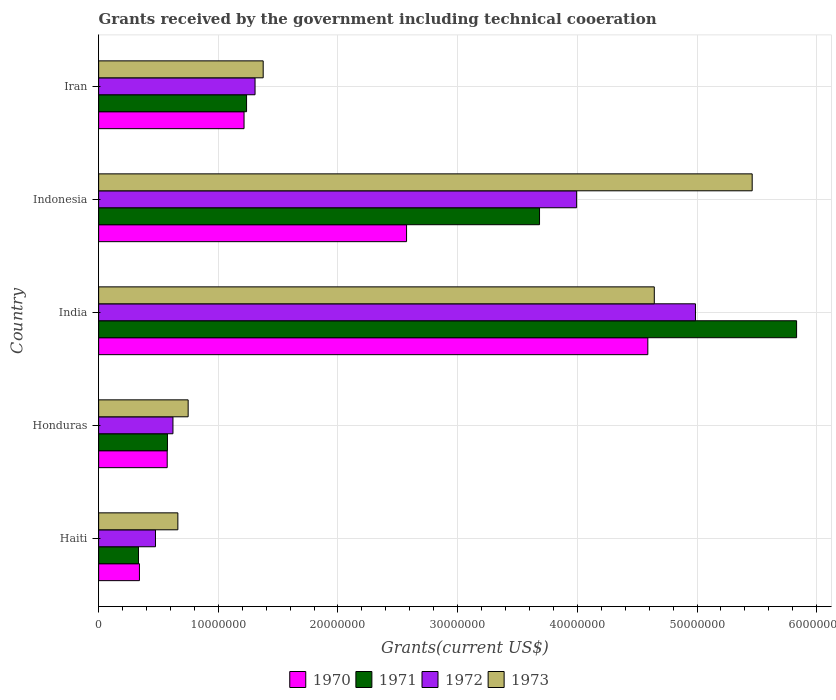How many groups of bars are there?
Your response must be concise. 5. Are the number of bars per tick equal to the number of legend labels?
Make the answer very short. Yes. Are the number of bars on each tick of the Y-axis equal?
Give a very brief answer. Yes. How many bars are there on the 1st tick from the top?
Your answer should be very brief. 4. What is the label of the 5th group of bars from the top?
Your answer should be very brief. Haiti. What is the total grants received by the government in 1973 in Indonesia?
Provide a short and direct response. 5.46e+07. Across all countries, what is the maximum total grants received by the government in 1973?
Your answer should be compact. 5.46e+07. Across all countries, what is the minimum total grants received by the government in 1970?
Make the answer very short. 3.41e+06. In which country was the total grants received by the government in 1972 minimum?
Your response must be concise. Haiti. What is the total total grants received by the government in 1970 in the graph?
Keep it short and to the point. 9.29e+07. What is the difference between the total grants received by the government in 1973 in India and that in Indonesia?
Provide a succinct answer. -8.18e+06. What is the difference between the total grants received by the government in 1971 in India and the total grants received by the government in 1972 in Honduras?
Offer a very short reply. 5.21e+07. What is the average total grants received by the government in 1972 per country?
Offer a terse response. 2.28e+07. What is the ratio of the total grants received by the government in 1971 in Honduras to that in India?
Your answer should be compact. 0.1. Is the total grants received by the government in 1970 in Honduras less than that in Indonesia?
Make the answer very short. Yes. What is the difference between the highest and the second highest total grants received by the government in 1970?
Ensure brevity in your answer.  2.02e+07. What is the difference between the highest and the lowest total grants received by the government in 1971?
Give a very brief answer. 5.50e+07. In how many countries, is the total grants received by the government in 1973 greater than the average total grants received by the government in 1973 taken over all countries?
Provide a short and direct response. 2. Is the sum of the total grants received by the government in 1973 in Honduras and Indonesia greater than the maximum total grants received by the government in 1970 across all countries?
Ensure brevity in your answer.  Yes. Is it the case that in every country, the sum of the total grants received by the government in 1973 and total grants received by the government in 1970 is greater than the sum of total grants received by the government in 1972 and total grants received by the government in 1971?
Your answer should be very brief. Yes. What does the 1st bar from the top in Iran represents?
Offer a very short reply. 1973. How many bars are there?
Keep it short and to the point. 20. Are all the bars in the graph horizontal?
Ensure brevity in your answer.  Yes. Does the graph contain any zero values?
Make the answer very short. No. Does the graph contain grids?
Make the answer very short. Yes. Where does the legend appear in the graph?
Your answer should be compact. Bottom center. How are the legend labels stacked?
Your response must be concise. Horizontal. What is the title of the graph?
Offer a terse response. Grants received by the government including technical cooeration. What is the label or title of the X-axis?
Offer a terse response. Grants(current US$). What is the Grants(current US$) in 1970 in Haiti?
Provide a short and direct response. 3.41e+06. What is the Grants(current US$) of 1971 in Haiti?
Provide a succinct answer. 3.33e+06. What is the Grants(current US$) in 1972 in Haiti?
Your answer should be very brief. 4.75e+06. What is the Grants(current US$) of 1973 in Haiti?
Offer a terse response. 6.62e+06. What is the Grants(current US$) in 1970 in Honduras?
Your answer should be compact. 5.73e+06. What is the Grants(current US$) of 1971 in Honduras?
Make the answer very short. 5.75e+06. What is the Grants(current US$) in 1972 in Honduras?
Give a very brief answer. 6.21e+06. What is the Grants(current US$) of 1973 in Honduras?
Make the answer very short. 7.48e+06. What is the Grants(current US$) in 1970 in India?
Your answer should be very brief. 4.59e+07. What is the Grants(current US$) of 1971 in India?
Make the answer very short. 5.83e+07. What is the Grants(current US$) in 1972 in India?
Provide a short and direct response. 4.99e+07. What is the Grants(current US$) of 1973 in India?
Provide a short and direct response. 4.64e+07. What is the Grants(current US$) in 1970 in Indonesia?
Provide a short and direct response. 2.57e+07. What is the Grants(current US$) in 1971 in Indonesia?
Your answer should be very brief. 3.68e+07. What is the Grants(current US$) of 1972 in Indonesia?
Your answer should be very brief. 3.99e+07. What is the Grants(current US$) of 1973 in Indonesia?
Offer a very short reply. 5.46e+07. What is the Grants(current US$) in 1970 in Iran?
Offer a terse response. 1.22e+07. What is the Grants(current US$) of 1971 in Iran?
Provide a succinct answer. 1.24e+07. What is the Grants(current US$) of 1972 in Iran?
Ensure brevity in your answer.  1.31e+07. What is the Grants(current US$) of 1973 in Iran?
Provide a short and direct response. 1.38e+07. Across all countries, what is the maximum Grants(current US$) in 1970?
Ensure brevity in your answer.  4.59e+07. Across all countries, what is the maximum Grants(current US$) of 1971?
Offer a very short reply. 5.83e+07. Across all countries, what is the maximum Grants(current US$) in 1972?
Offer a very short reply. 4.99e+07. Across all countries, what is the maximum Grants(current US$) in 1973?
Provide a short and direct response. 5.46e+07. Across all countries, what is the minimum Grants(current US$) of 1970?
Give a very brief answer. 3.41e+06. Across all countries, what is the minimum Grants(current US$) in 1971?
Offer a terse response. 3.33e+06. Across all countries, what is the minimum Grants(current US$) in 1972?
Offer a very short reply. 4.75e+06. Across all countries, what is the minimum Grants(current US$) in 1973?
Provide a succinct answer. 6.62e+06. What is the total Grants(current US$) of 1970 in the graph?
Keep it short and to the point. 9.29e+07. What is the total Grants(current US$) of 1971 in the graph?
Your response must be concise. 1.17e+08. What is the total Grants(current US$) of 1972 in the graph?
Provide a short and direct response. 1.14e+08. What is the total Grants(current US$) of 1973 in the graph?
Your response must be concise. 1.29e+08. What is the difference between the Grants(current US$) of 1970 in Haiti and that in Honduras?
Provide a succinct answer. -2.32e+06. What is the difference between the Grants(current US$) of 1971 in Haiti and that in Honduras?
Offer a very short reply. -2.42e+06. What is the difference between the Grants(current US$) in 1972 in Haiti and that in Honduras?
Provide a short and direct response. -1.46e+06. What is the difference between the Grants(current US$) of 1973 in Haiti and that in Honduras?
Ensure brevity in your answer.  -8.60e+05. What is the difference between the Grants(current US$) of 1970 in Haiti and that in India?
Offer a very short reply. -4.25e+07. What is the difference between the Grants(current US$) of 1971 in Haiti and that in India?
Your answer should be compact. -5.50e+07. What is the difference between the Grants(current US$) in 1972 in Haiti and that in India?
Your answer should be compact. -4.51e+07. What is the difference between the Grants(current US$) of 1973 in Haiti and that in India?
Offer a very short reply. -3.98e+07. What is the difference between the Grants(current US$) of 1970 in Haiti and that in Indonesia?
Keep it short and to the point. -2.23e+07. What is the difference between the Grants(current US$) in 1971 in Haiti and that in Indonesia?
Ensure brevity in your answer.  -3.35e+07. What is the difference between the Grants(current US$) of 1972 in Haiti and that in Indonesia?
Offer a terse response. -3.52e+07. What is the difference between the Grants(current US$) of 1973 in Haiti and that in Indonesia?
Offer a very short reply. -4.80e+07. What is the difference between the Grants(current US$) of 1970 in Haiti and that in Iran?
Provide a succinct answer. -8.74e+06. What is the difference between the Grants(current US$) in 1971 in Haiti and that in Iran?
Keep it short and to the point. -9.03e+06. What is the difference between the Grants(current US$) in 1972 in Haiti and that in Iran?
Keep it short and to the point. -8.32e+06. What is the difference between the Grants(current US$) of 1973 in Haiti and that in Iran?
Offer a very short reply. -7.13e+06. What is the difference between the Grants(current US$) in 1970 in Honduras and that in India?
Give a very brief answer. -4.02e+07. What is the difference between the Grants(current US$) of 1971 in Honduras and that in India?
Provide a succinct answer. -5.26e+07. What is the difference between the Grants(current US$) in 1972 in Honduras and that in India?
Ensure brevity in your answer.  -4.37e+07. What is the difference between the Grants(current US$) of 1973 in Honduras and that in India?
Make the answer very short. -3.90e+07. What is the difference between the Grants(current US$) of 1970 in Honduras and that in Indonesia?
Offer a terse response. -2.00e+07. What is the difference between the Grants(current US$) of 1971 in Honduras and that in Indonesia?
Offer a very short reply. -3.11e+07. What is the difference between the Grants(current US$) in 1972 in Honduras and that in Indonesia?
Provide a succinct answer. -3.37e+07. What is the difference between the Grants(current US$) of 1973 in Honduras and that in Indonesia?
Offer a terse response. -4.71e+07. What is the difference between the Grants(current US$) in 1970 in Honduras and that in Iran?
Keep it short and to the point. -6.42e+06. What is the difference between the Grants(current US$) in 1971 in Honduras and that in Iran?
Make the answer very short. -6.61e+06. What is the difference between the Grants(current US$) in 1972 in Honduras and that in Iran?
Ensure brevity in your answer.  -6.86e+06. What is the difference between the Grants(current US$) in 1973 in Honduras and that in Iran?
Your response must be concise. -6.27e+06. What is the difference between the Grants(current US$) in 1970 in India and that in Indonesia?
Offer a terse response. 2.02e+07. What is the difference between the Grants(current US$) in 1971 in India and that in Indonesia?
Your answer should be very brief. 2.15e+07. What is the difference between the Grants(current US$) of 1972 in India and that in Indonesia?
Make the answer very short. 9.93e+06. What is the difference between the Grants(current US$) in 1973 in India and that in Indonesia?
Ensure brevity in your answer.  -8.18e+06. What is the difference between the Grants(current US$) in 1970 in India and that in Iran?
Keep it short and to the point. 3.37e+07. What is the difference between the Grants(current US$) in 1971 in India and that in Iran?
Your response must be concise. 4.60e+07. What is the difference between the Grants(current US$) in 1972 in India and that in Iran?
Provide a short and direct response. 3.68e+07. What is the difference between the Grants(current US$) of 1973 in India and that in Iran?
Ensure brevity in your answer.  3.27e+07. What is the difference between the Grants(current US$) of 1970 in Indonesia and that in Iran?
Your response must be concise. 1.36e+07. What is the difference between the Grants(current US$) of 1971 in Indonesia and that in Iran?
Ensure brevity in your answer.  2.45e+07. What is the difference between the Grants(current US$) in 1972 in Indonesia and that in Iran?
Give a very brief answer. 2.69e+07. What is the difference between the Grants(current US$) of 1973 in Indonesia and that in Iran?
Ensure brevity in your answer.  4.09e+07. What is the difference between the Grants(current US$) in 1970 in Haiti and the Grants(current US$) in 1971 in Honduras?
Provide a short and direct response. -2.34e+06. What is the difference between the Grants(current US$) in 1970 in Haiti and the Grants(current US$) in 1972 in Honduras?
Keep it short and to the point. -2.80e+06. What is the difference between the Grants(current US$) of 1970 in Haiti and the Grants(current US$) of 1973 in Honduras?
Your answer should be very brief. -4.07e+06. What is the difference between the Grants(current US$) of 1971 in Haiti and the Grants(current US$) of 1972 in Honduras?
Offer a very short reply. -2.88e+06. What is the difference between the Grants(current US$) in 1971 in Haiti and the Grants(current US$) in 1973 in Honduras?
Make the answer very short. -4.15e+06. What is the difference between the Grants(current US$) of 1972 in Haiti and the Grants(current US$) of 1973 in Honduras?
Offer a very short reply. -2.73e+06. What is the difference between the Grants(current US$) of 1970 in Haiti and the Grants(current US$) of 1971 in India?
Offer a very short reply. -5.49e+07. What is the difference between the Grants(current US$) in 1970 in Haiti and the Grants(current US$) in 1972 in India?
Your answer should be compact. -4.65e+07. What is the difference between the Grants(current US$) of 1970 in Haiti and the Grants(current US$) of 1973 in India?
Keep it short and to the point. -4.30e+07. What is the difference between the Grants(current US$) in 1971 in Haiti and the Grants(current US$) in 1972 in India?
Offer a terse response. -4.65e+07. What is the difference between the Grants(current US$) of 1971 in Haiti and the Grants(current US$) of 1973 in India?
Provide a succinct answer. -4.31e+07. What is the difference between the Grants(current US$) of 1972 in Haiti and the Grants(current US$) of 1973 in India?
Your answer should be very brief. -4.17e+07. What is the difference between the Grants(current US$) in 1970 in Haiti and the Grants(current US$) in 1971 in Indonesia?
Make the answer very short. -3.34e+07. What is the difference between the Grants(current US$) in 1970 in Haiti and the Grants(current US$) in 1972 in Indonesia?
Provide a succinct answer. -3.65e+07. What is the difference between the Grants(current US$) of 1970 in Haiti and the Grants(current US$) of 1973 in Indonesia?
Ensure brevity in your answer.  -5.12e+07. What is the difference between the Grants(current US$) of 1971 in Haiti and the Grants(current US$) of 1972 in Indonesia?
Provide a succinct answer. -3.66e+07. What is the difference between the Grants(current US$) of 1971 in Haiti and the Grants(current US$) of 1973 in Indonesia?
Make the answer very short. -5.13e+07. What is the difference between the Grants(current US$) in 1972 in Haiti and the Grants(current US$) in 1973 in Indonesia?
Ensure brevity in your answer.  -4.99e+07. What is the difference between the Grants(current US$) of 1970 in Haiti and the Grants(current US$) of 1971 in Iran?
Ensure brevity in your answer.  -8.95e+06. What is the difference between the Grants(current US$) in 1970 in Haiti and the Grants(current US$) in 1972 in Iran?
Your response must be concise. -9.66e+06. What is the difference between the Grants(current US$) in 1970 in Haiti and the Grants(current US$) in 1973 in Iran?
Provide a short and direct response. -1.03e+07. What is the difference between the Grants(current US$) of 1971 in Haiti and the Grants(current US$) of 1972 in Iran?
Provide a short and direct response. -9.74e+06. What is the difference between the Grants(current US$) of 1971 in Haiti and the Grants(current US$) of 1973 in Iran?
Give a very brief answer. -1.04e+07. What is the difference between the Grants(current US$) in 1972 in Haiti and the Grants(current US$) in 1973 in Iran?
Provide a succinct answer. -9.00e+06. What is the difference between the Grants(current US$) of 1970 in Honduras and the Grants(current US$) of 1971 in India?
Provide a short and direct response. -5.26e+07. What is the difference between the Grants(current US$) of 1970 in Honduras and the Grants(current US$) of 1972 in India?
Your answer should be very brief. -4.41e+07. What is the difference between the Grants(current US$) in 1970 in Honduras and the Grants(current US$) in 1973 in India?
Offer a very short reply. -4.07e+07. What is the difference between the Grants(current US$) of 1971 in Honduras and the Grants(current US$) of 1972 in India?
Offer a terse response. -4.41e+07. What is the difference between the Grants(current US$) in 1971 in Honduras and the Grants(current US$) in 1973 in India?
Your answer should be very brief. -4.07e+07. What is the difference between the Grants(current US$) of 1972 in Honduras and the Grants(current US$) of 1973 in India?
Give a very brief answer. -4.02e+07. What is the difference between the Grants(current US$) in 1970 in Honduras and the Grants(current US$) in 1971 in Indonesia?
Give a very brief answer. -3.11e+07. What is the difference between the Grants(current US$) in 1970 in Honduras and the Grants(current US$) in 1972 in Indonesia?
Your answer should be very brief. -3.42e+07. What is the difference between the Grants(current US$) in 1970 in Honduras and the Grants(current US$) in 1973 in Indonesia?
Give a very brief answer. -4.89e+07. What is the difference between the Grants(current US$) in 1971 in Honduras and the Grants(current US$) in 1972 in Indonesia?
Make the answer very short. -3.42e+07. What is the difference between the Grants(current US$) in 1971 in Honduras and the Grants(current US$) in 1973 in Indonesia?
Provide a succinct answer. -4.89e+07. What is the difference between the Grants(current US$) of 1972 in Honduras and the Grants(current US$) of 1973 in Indonesia?
Provide a short and direct response. -4.84e+07. What is the difference between the Grants(current US$) in 1970 in Honduras and the Grants(current US$) in 1971 in Iran?
Offer a terse response. -6.63e+06. What is the difference between the Grants(current US$) in 1970 in Honduras and the Grants(current US$) in 1972 in Iran?
Your answer should be compact. -7.34e+06. What is the difference between the Grants(current US$) of 1970 in Honduras and the Grants(current US$) of 1973 in Iran?
Your answer should be compact. -8.02e+06. What is the difference between the Grants(current US$) in 1971 in Honduras and the Grants(current US$) in 1972 in Iran?
Provide a short and direct response. -7.32e+06. What is the difference between the Grants(current US$) in 1971 in Honduras and the Grants(current US$) in 1973 in Iran?
Provide a succinct answer. -8.00e+06. What is the difference between the Grants(current US$) in 1972 in Honduras and the Grants(current US$) in 1973 in Iran?
Your response must be concise. -7.54e+06. What is the difference between the Grants(current US$) of 1970 in India and the Grants(current US$) of 1971 in Indonesia?
Ensure brevity in your answer.  9.05e+06. What is the difference between the Grants(current US$) in 1970 in India and the Grants(current US$) in 1972 in Indonesia?
Offer a terse response. 5.95e+06. What is the difference between the Grants(current US$) in 1970 in India and the Grants(current US$) in 1973 in Indonesia?
Your response must be concise. -8.72e+06. What is the difference between the Grants(current US$) in 1971 in India and the Grants(current US$) in 1972 in Indonesia?
Your answer should be very brief. 1.84e+07. What is the difference between the Grants(current US$) in 1971 in India and the Grants(current US$) in 1973 in Indonesia?
Offer a very short reply. 3.71e+06. What is the difference between the Grants(current US$) in 1972 in India and the Grants(current US$) in 1973 in Indonesia?
Offer a very short reply. -4.74e+06. What is the difference between the Grants(current US$) in 1970 in India and the Grants(current US$) in 1971 in Iran?
Offer a terse response. 3.35e+07. What is the difference between the Grants(current US$) in 1970 in India and the Grants(current US$) in 1972 in Iran?
Offer a terse response. 3.28e+07. What is the difference between the Grants(current US$) of 1970 in India and the Grants(current US$) of 1973 in Iran?
Keep it short and to the point. 3.21e+07. What is the difference between the Grants(current US$) of 1971 in India and the Grants(current US$) of 1972 in Iran?
Provide a short and direct response. 4.52e+07. What is the difference between the Grants(current US$) of 1971 in India and the Grants(current US$) of 1973 in Iran?
Offer a terse response. 4.46e+07. What is the difference between the Grants(current US$) in 1972 in India and the Grants(current US$) in 1973 in Iran?
Give a very brief answer. 3.61e+07. What is the difference between the Grants(current US$) in 1970 in Indonesia and the Grants(current US$) in 1971 in Iran?
Your answer should be compact. 1.34e+07. What is the difference between the Grants(current US$) in 1970 in Indonesia and the Grants(current US$) in 1972 in Iran?
Offer a terse response. 1.27e+07. What is the difference between the Grants(current US$) of 1970 in Indonesia and the Grants(current US$) of 1973 in Iran?
Offer a terse response. 1.20e+07. What is the difference between the Grants(current US$) in 1971 in Indonesia and the Grants(current US$) in 1972 in Iran?
Make the answer very short. 2.38e+07. What is the difference between the Grants(current US$) in 1971 in Indonesia and the Grants(current US$) in 1973 in Iran?
Your response must be concise. 2.31e+07. What is the difference between the Grants(current US$) of 1972 in Indonesia and the Grants(current US$) of 1973 in Iran?
Provide a short and direct response. 2.62e+07. What is the average Grants(current US$) in 1970 per country?
Provide a succinct answer. 1.86e+07. What is the average Grants(current US$) in 1971 per country?
Ensure brevity in your answer.  2.33e+07. What is the average Grants(current US$) in 1972 per country?
Offer a terse response. 2.28e+07. What is the average Grants(current US$) in 1973 per country?
Provide a succinct answer. 2.58e+07. What is the difference between the Grants(current US$) of 1970 and Grants(current US$) of 1972 in Haiti?
Make the answer very short. -1.34e+06. What is the difference between the Grants(current US$) in 1970 and Grants(current US$) in 1973 in Haiti?
Provide a succinct answer. -3.21e+06. What is the difference between the Grants(current US$) of 1971 and Grants(current US$) of 1972 in Haiti?
Your response must be concise. -1.42e+06. What is the difference between the Grants(current US$) in 1971 and Grants(current US$) in 1973 in Haiti?
Give a very brief answer. -3.29e+06. What is the difference between the Grants(current US$) in 1972 and Grants(current US$) in 1973 in Haiti?
Your answer should be compact. -1.87e+06. What is the difference between the Grants(current US$) of 1970 and Grants(current US$) of 1971 in Honduras?
Provide a succinct answer. -2.00e+04. What is the difference between the Grants(current US$) of 1970 and Grants(current US$) of 1972 in Honduras?
Your answer should be compact. -4.80e+05. What is the difference between the Grants(current US$) in 1970 and Grants(current US$) in 1973 in Honduras?
Offer a very short reply. -1.75e+06. What is the difference between the Grants(current US$) in 1971 and Grants(current US$) in 1972 in Honduras?
Offer a terse response. -4.60e+05. What is the difference between the Grants(current US$) of 1971 and Grants(current US$) of 1973 in Honduras?
Keep it short and to the point. -1.73e+06. What is the difference between the Grants(current US$) in 1972 and Grants(current US$) in 1973 in Honduras?
Offer a terse response. -1.27e+06. What is the difference between the Grants(current US$) in 1970 and Grants(current US$) in 1971 in India?
Your answer should be very brief. -1.24e+07. What is the difference between the Grants(current US$) in 1970 and Grants(current US$) in 1972 in India?
Make the answer very short. -3.98e+06. What is the difference between the Grants(current US$) of 1970 and Grants(current US$) of 1973 in India?
Provide a succinct answer. -5.40e+05. What is the difference between the Grants(current US$) of 1971 and Grants(current US$) of 1972 in India?
Offer a terse response. 8.45e+06. What is the difference between the Grants(current US$) in 1971 and Grants(current US$) in 1973 in India?
Offer a very short reply. 1.19e+07. What is the difference between the Grants(current US$) of 1972 and Grants(current US$) of 1973 in India?
Keep it short and to the point. 3.44e+06. What is the difference between the Grants(current US$) of 1970 and Grants(current US$) of 1971 in Indonesia?
Offer a very short reply. -1.11e+07. What is the difference between the Grants(current US$) in 1970 and Grants(current US$) in 1972 in Indonesia?
Keep it short and to the point. -1.42e+07. What is the difference between the Grants(current US$) in 1970 and Grants(current US$) in 1973 in Indonesia?
Offer a very short reply. -2.89e+07. What is the difference between the Grants(current US$) of 1971 and Grants(current US$) of 1972 in Indonesia?
Offer a very short reply. -3.10e+06. What is the difference between the Grants(current US$) of 1971 and Grants(current US$) of 1973 in Indonesia?
Your response must be concise. -1.78e+07. What is the difference between the Grants(current US$) of 1972 and Grants(current US$) of 1973 in Indonesia?
Make the answer very short. -1.47e+07. What is the difference between the Grants(current US$) of 1970 and Grants(current US$) of 1972 in Iran?
Ensure brevity in your answer.  -9.20e+05. What is the difference between the Grants(current US$) of 1970 and Grants(current US$) of 1973 in Iran?
Ensure brevity in your answer.  -1.60e+06. What is the difference between the Grants(current US$) in 1971 and Grants(current US$) in 1972 in Iran?
Keep it short and to the point. -7.10e+05. What is the difference between the Grants(current US$) of 1971 and Grants(current US$) of 1973 in Iran?
Provide a short and direct response. -1.39e+06. What is the difference between the Grants(current US$) in 1972 and Grants(current US$) in 1973 in Iran?
Provide a short and direct response. -6.80e+05. What is the ratio of the Grants(current US$) of 1970 in Haiti to that in Honduras?
Your response must be concise. 0.6. What is the ratio of the Grants(current US$) in 1971 in Haiti to that in Honduras?
Your answer should be compact. 0.58. What is the ratio of the Grants(current US$) in 1972 in Haiti to that in Honduras?
Make the answer very short. 0.76. What is the ratio of the Grants(current US$) of 1973 in Haiti to that in Honduras?
Give a very brief answer. 0.89. What is the ratio of the Grants(current US$) in 1970 in Haiti to that in India?
Provide a succinct answer. 0.07. What is the ratio of the Grants(current US$) of 1971 in Haiti to that in India?
Offer a terse response. 0.06. What is the ratio of the Grants(current US$) in 1972 in Haiti to that in India?
Your response must be concise. 0.1. What is the ratio of the Grants(current US$) in 1973 in Haiti to that in India?
Your answer should be compact. 0.14. What is the ratio of the Grants(current US$) of 1970 in Haiti to that in Indonesia?
Offer a very short reply. 0.13. What is the ratio of the Grants(current US$) in 1971 in Haiti to that in Indonesia?
Offer a very short reply. 0.09. What is the ratio of the Grants(current US$) in 1972 in Haiti to that in Indonesia?
Provide a short and direct response. 0.12. What is the ratio of the Grants(current US$) in 1973 in Haiti to that in Indonesia?
Offer a very short reply. 0.12. What is the ratio of the Grants(current US$) in 1970 in Haiti to that in Iran?
Your response must be concise. 0.28. What is the ratio of the Grants(current US$) of 1971 in Haiti to that in Iran?
Your answer should be very brief. 0.27. What is the ratio of the Grants(current US$) of 1972 in Haiti to that in Iran?
Ensure brevity in your answer.  0.36. What is the ratio of the Grants(current US$) of 1973 in Haiti to that in Iran?
Your answer should be compact. 0.48. What is the ratio of the Grants(current US$) of 1970 in Honduras to that in India?
Provide a short and direct response. 0.12. What is the ratio of the Grants(current US$) in 1971 in Honduras to that in India?
Your response must be concise. 0.1. What is the ratio of the Grants(current US$) of 1972 in Honduras to that in India?
Your answer should be very brief. 0.12. What is the ratio of the Grants(current US$) of 1973 in Honduras to that in India?
Your response must be concise. 0.16. What is the ratio of the Grants(current US$) of 1970 in Honduras to that in Indonesia?
Offer a very short reply. 0.22. What is the ratio of the Grants(current US$) of 1971 in Honduras to that in Indonesia?
Give a very brief answer. 0.16. What is the ratio of the Grants(current US$) in 1972 in Honduras to that in Indonesia?
Provide a succinct answer. 0.16. What is the ratio of the Grants(current US$) in 1973 in Honduras to that in Indonesia?
Your answer should be very brief. 0.14. What is the ratio of the Grants(current US$) in 1970 in Honduras to that in Iran?
Provide a succinct answer. 0.47. What is the ratio of the Grants(current US$) in 1971 in Honduras to that in Iran?
Offer a terse response. 0.47. What is the ratio of the Grants(current US$) of 1972 in Honduras to that in Iran?
Your answer should be very brief. 0.48. What is the ratio of the Grants(current US$) of 1973 in Honduras to that in Iran?
Your answer should be very brief. 0.54. What is the ratio of the Grants(current US$) in 1970 in India to that in Indonesia?
Your answer should be very brief. 1.78. What is the ratio of the Grants(current US$) in 1971 in India to that in Indonesia?
Keep it short and to the point. 1.58. What is the ratio of the Grants(current US$) of 1972 in India to that in Indonesia?
Keep it short and to the point. 1.25. What is the ratio of the Grants(current US$) in 1973 in India to that in Indonesia?
Your response must be concise. 0.85. What is the ratio of the Grants(current US$) in 1970 in India to that in Iran?
Your response must be concise. 3.78. What is the ratio of the Grants(current US$) in 1971 in India to that in Iran?
Offer a very short reply. 4.72. What is the ratio of the Grants(current US$) of 1972 in India to that in Iran?
Provide a succinct answer. 3.82. What is the ratio of the Grants(current US$) of 1973 in India to that in Iran?
Provide a short and direct response. 3.38. What is the ratio of the Grants(current US$) in 1970 in Indonesia to that in Iran?
Provide a succinct answer. 2.12. What is the ratio of the Grants(current US$) of 1971 in Indonesia to that in Iran?
Offer a very short reply. 2.98. What is the ratio of the Grants(current US$) in 1972 in Indonesia to that in Iran?
Your response must be concise. 3.06. What is the ratio of the Grants(current US$) in 1973 in Indonesia to that in Iran?
Give a very brief answer. 3.97. What is the difference between the highest and the second highest Grants(current US$) in 1970?
Make the answer very short. 2.02e+07. What is the difference between the highest and the second highest Grants(current US$) of 1971?
Make the answer very short. 2.15e+07. What is the difference between the highest and the second highest Grants(current US$) in 1972?
Provide a short and direct response. 9.93e+06. What is the difference between the highest and the second highest Grants(current US$) of 1973?
Keep it short and to the point. 8.18e+06. What is the difference between the highest and the lowest Grants(current US$) in 1970?
Offer a very short reply. 4.25e+07. What is the difference between the highest and the lowest Grants(current US$) of 1971?
Ensure brevity in your answer.  5.50e+07. What is the difference between the highest and the lowest Grants(current US$) in 1972?
Provide a succinct answer. 4.51e+07. What is the difference between the highest and the lowest Grants(current US$) in 1973?
Provide a short and direct response. 4.80e+07. 